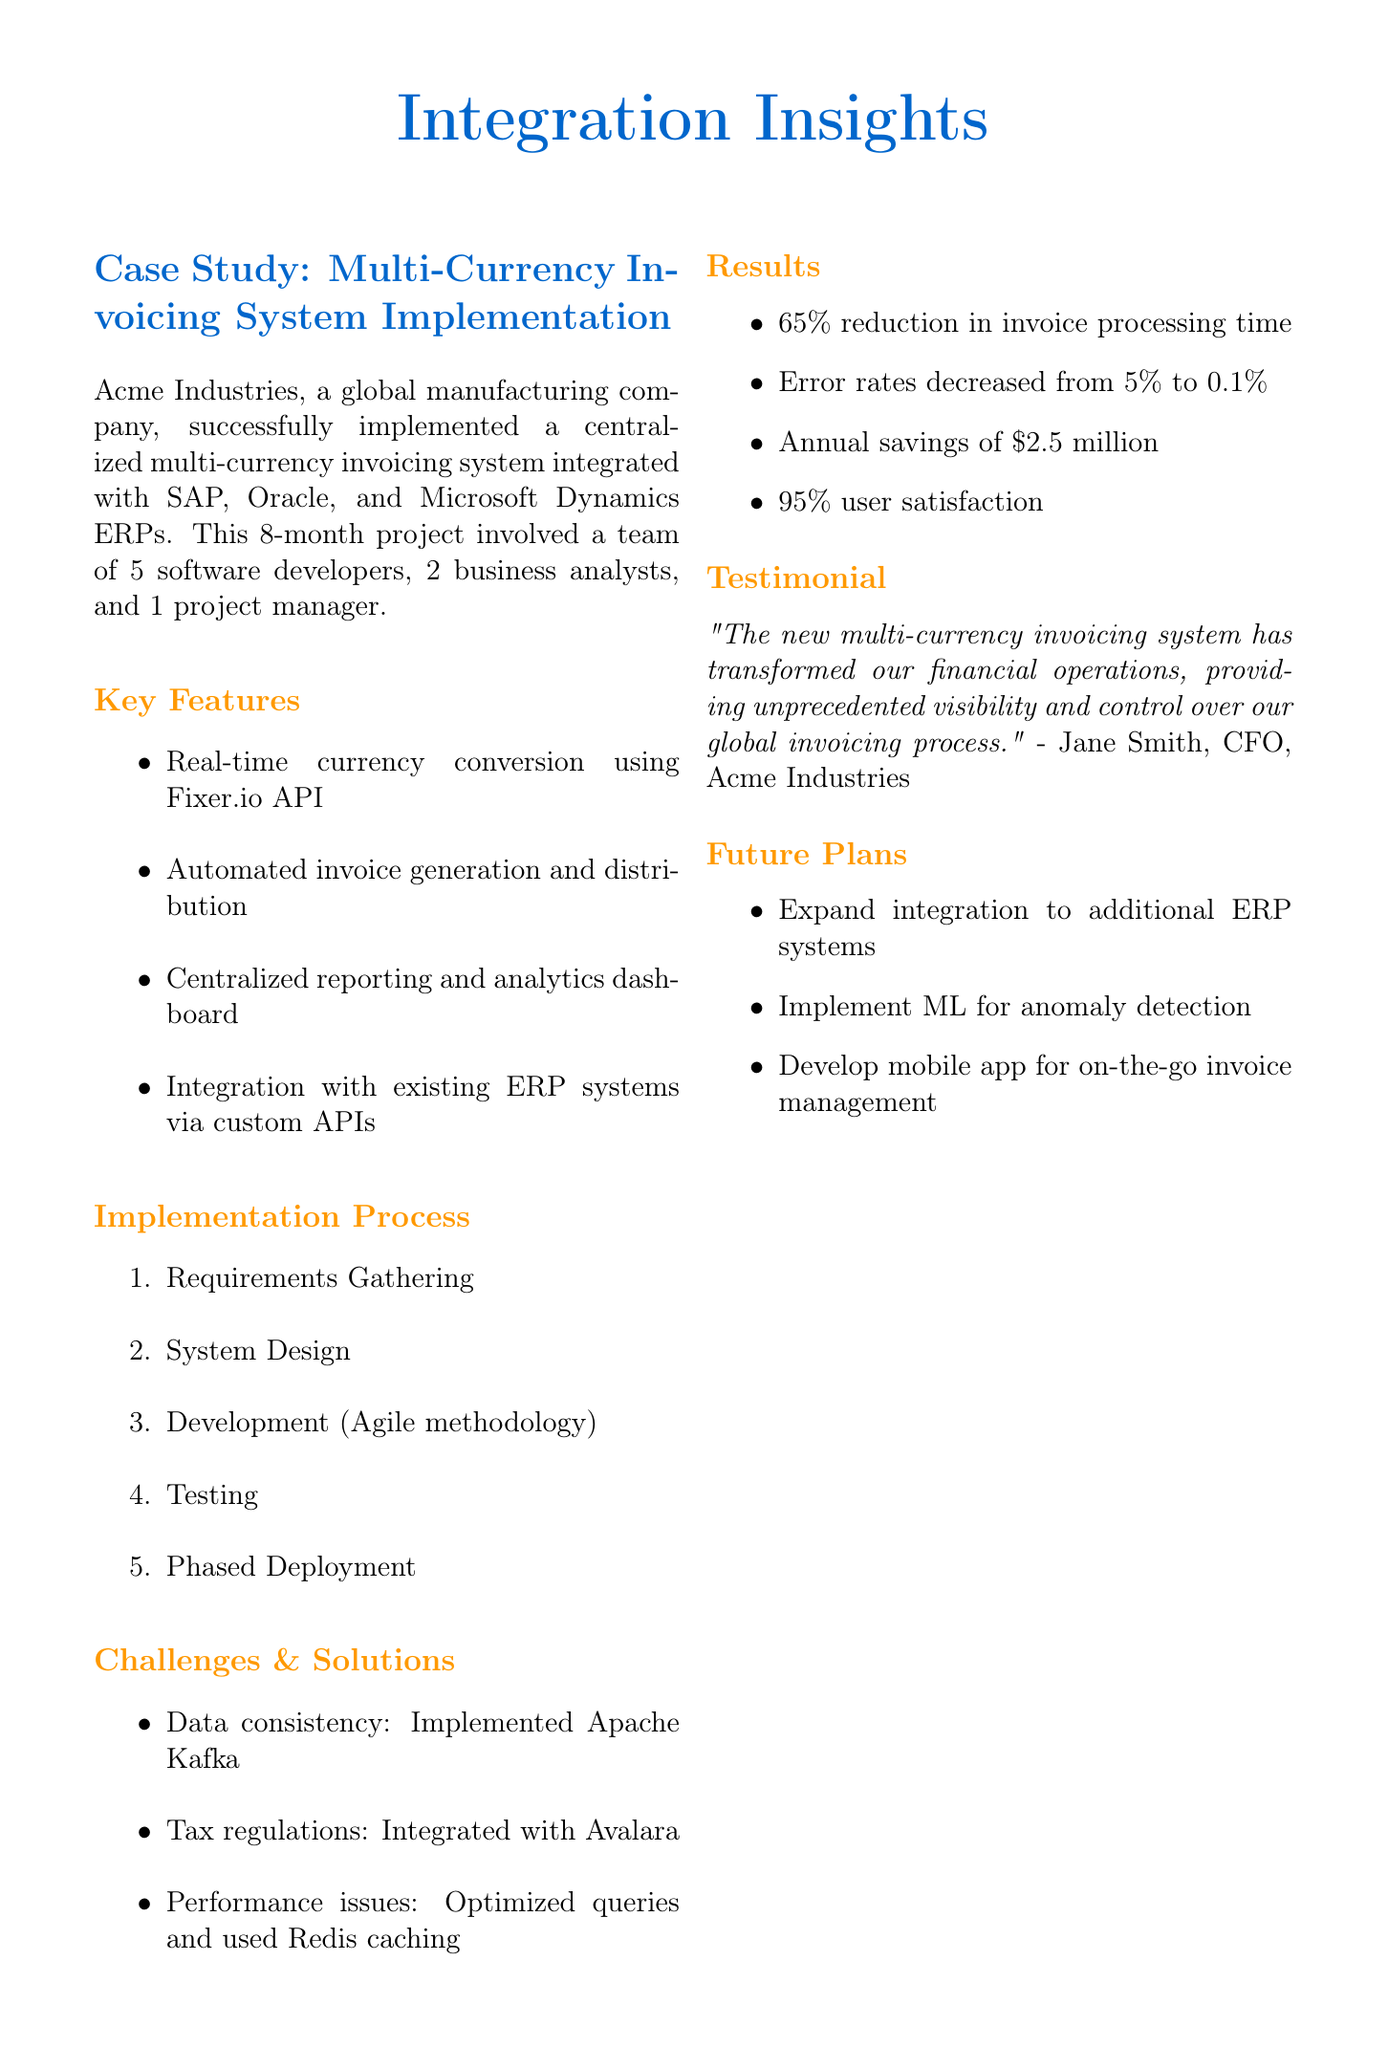What was the duration of the project? The duration of the project is mentioned as 8 months in the document.
Answer: 8 months Who gave the testimonial in the case study? Jane Smith, the CFO of Acme Industries, provided the testimonial.
Answer: Jane Smith What was the reduction in invoice processing time? The document states that the invoice processing time was reduced by 65%.
Answer: 65% Which technology was used for real-time currency conversion? The document specifically mentions the Fixer.io API for real-time currency conversion.
Answer: Fixer.io API What is one of the future plans mentioned in the document? The document lists several future plans; one of them is to implement machine learning for anomaly detection.
Answer: Implement machine learning for anomaly detection What methodology was utilized during development? The Agile methodology was used during the development phase according to the document.
Answer: Agile methodology What were the annual savings achieved? The document states that there were annual savings of $2.5 million in operational costs.
Answer: $2.5 million What percentage of users reported improved efficiency? According to the document, 95% of users reported improved efficiency in managing multi-currency invoices.
Answer: 95% 